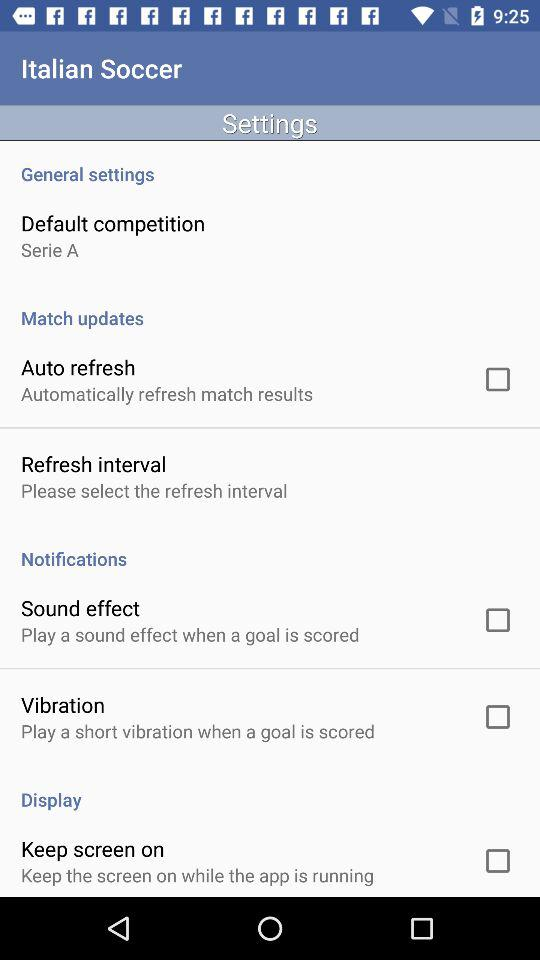What is the setting for the default competition? The setting for the default competition is "Serie A". 